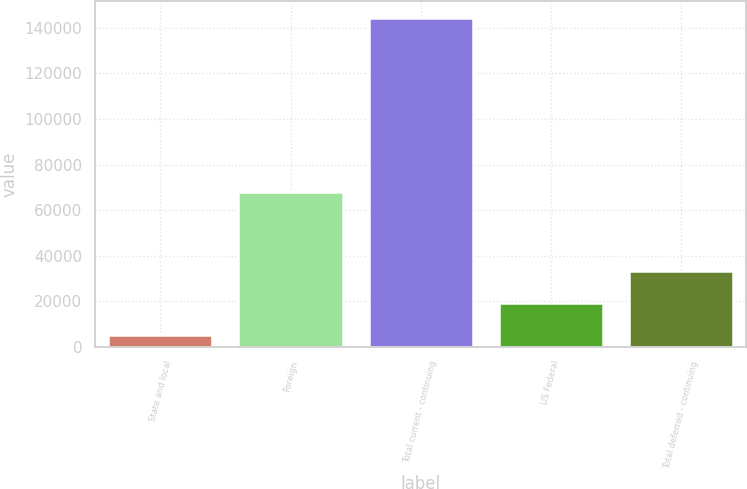Convert chart. <chart><loc_0><loc_0><loc_500><loc_500><bar_chart><fcel>State and local<fcel>Foreign<fcel>Total current - continuing<fcel>US Federal<fcel>Total deferred - continuing<nl><fcel>5191<fcel>68065<fcel>144525<fcel>19124.4<fcel>33057.8<nl></chart> 